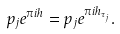<formula> <loc_0><loc_0><loc_500><loc_500>p _ { j } e ^ { \pi i h } = p _ { j } e ^ { \pi i h _ { \tau _ { j } } } .</formula> 